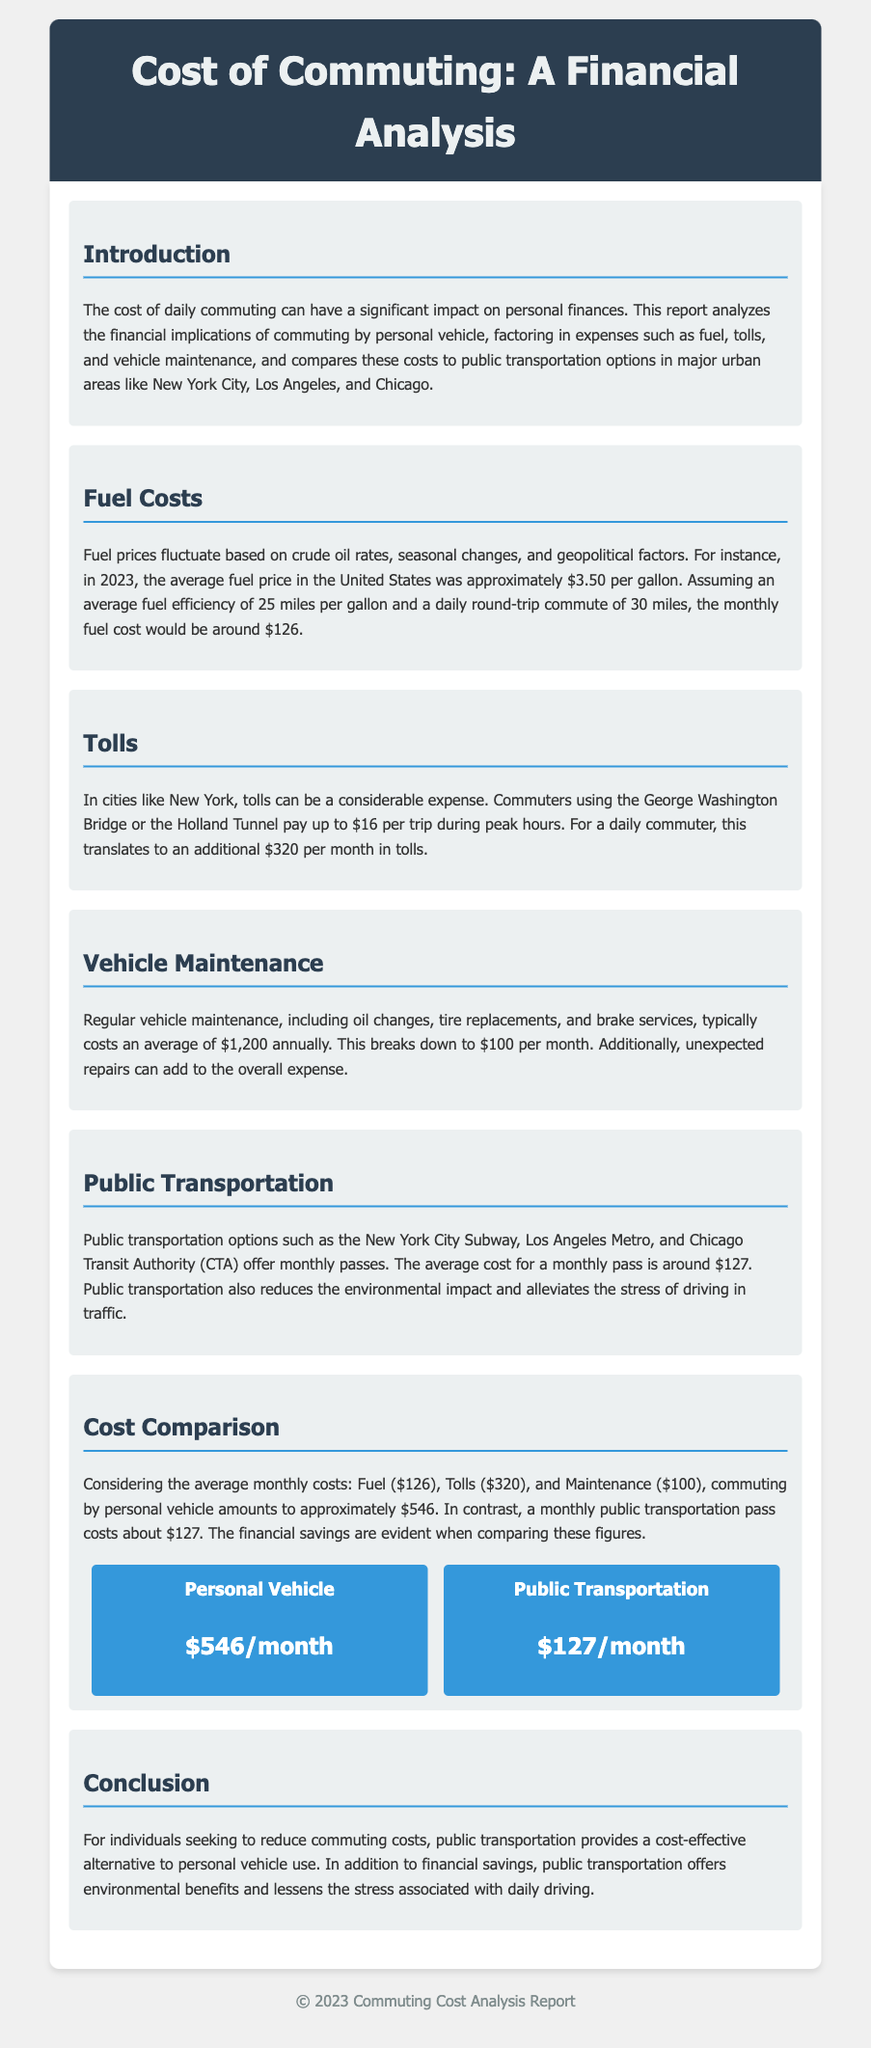What is the average fuel price in 2023? The document lists the average fuel price in the United States in 2023 as $3.50 per gallon.
Answer: $3.50 per gallon What is the monthly cost of fuel for a daily round-trip commute of 30 miles? According to the report, the monthly fuel cost for such a commute would be around $126.
Answer: $126 How much do commuters pay in tolls per month when using the George Washington Bridge or Holland Tunnel? The document states that for daily commuters, this translates to an additional $320 per month in tolls.
Answer: $320 What is the average monthly cost for vehicle maintenance? The report indicates that regular vehicle maintenance costs an average of $100 per month.
Answer: $100 How much does a monthly public transportation pass cost? The analysis in the report mentions that the average cost for a monthly pass is around $127.
Answer: $127 What is the total monthly cost of commuting by personal vehicle? The document concludes that commuting by personal vehicle amounts to approximately $546 per month.
Answer: $546 Which commuting option is more cost-effective based on the report? The report highlights that public transportation provides a cost-effective alternative to personal vehicle use.
Answer: Public transportation What impact does public transportation have on the environment? It is noted in the document that public transportation reduces the environmental impact.
Answer: Reduces environmental impact Which urban areas are mentioned in relation to public transportation options? The cities mentioned are New York City, Los Angeles, and Chicago.
Answer: New York City, Los Angeles, Chicago 